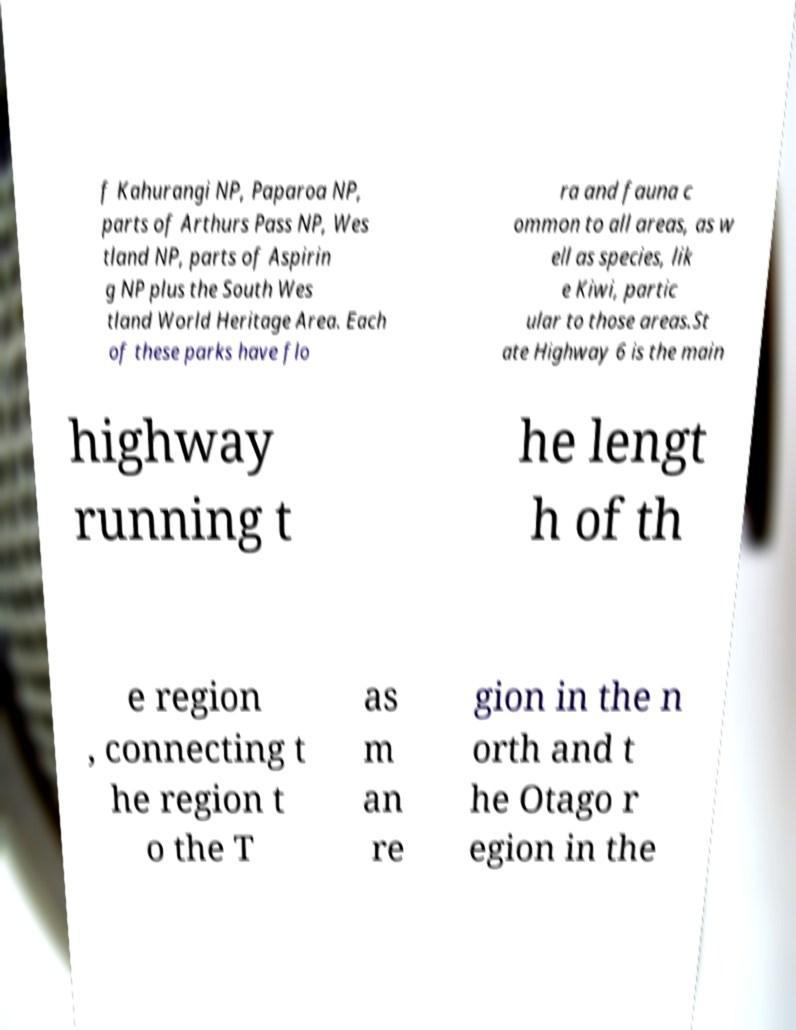For documentation purposes, I need the text within this image transcribed. Could you provide that? f Kahurangi NP, Paparoa NP, parts of Arthurs Pass NP, Wes tland NP, parts of Aspirin g NP plus the South Wes tland World Heritage Area. Each of these parks have flo ra and fauna c ommon to all areas, as w ell as species, lik e Kiwi, partic ular to those areas.St ate Highway 6 is the main highway running t he lengt h of th e region , connecting t he region t o the T as m an re gion in the n orth and t he Otago r egion in the 